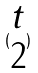<formula> <loc_0><loc_0><loc_500><loc_500>( \begin{matrix} t \\ 2 \end{matrix} )</formula> 